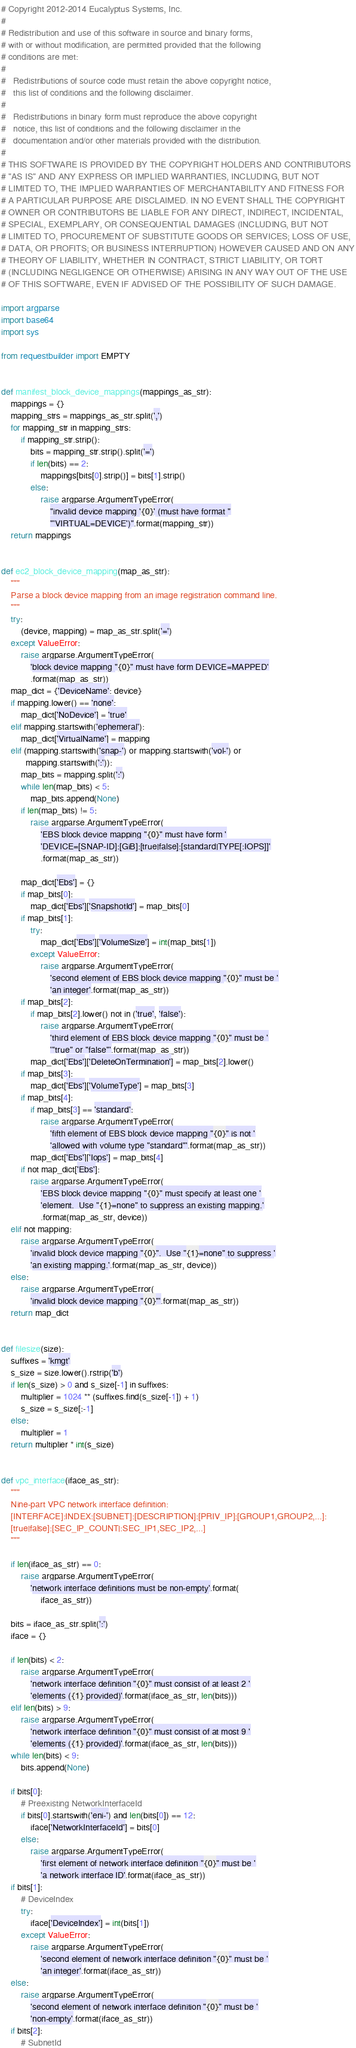<code> <loc_0><loc_0><loc_500><loc_500><_Python_># Copyright 2012-2014 Eucalyptus Systems, Inc.
#
# Redistribution and use of this software in source and binary forms,
# with or without modification, are permitted provided that the following
# conditions are met:
#
#   Redistributions of source code must retain the above copyright notice,
#   this list of conditions and the following disclaimer.
#
#   Redistributions in binary form must reproduce the above copyright
#   notice, this list of conditions and the following disclaimer in the
#   documentation and/or other materials provided with the distribution.
#
# THIS SOFTWARE IS PROVIDED BY THE COPYRIGHT HOLDERS AND CONTRIBUTORS
# "AS IS" AND ANY EXPRESS OR IMPLIED WARRANTIES, INCLUDING, BUT NOT
# LIMITED TO, THE IMPLIED WARRANTIES OF MERCHANTABILITY AND FITNESS FOR
# A PARTICULAR PURPOSE ARE DISCLAIMED. IN NO EVENT SHALL THE COPYRIGHT
# OWNER OR CONTRIBUTORS BE LIABLE FOR ANY DIRECT, INDIRECT, INCIDENTAL,
# SPECIAL, EXEMPLARY, OR CONSEQUENTIAL DAMAGES (INCLUDING, BUT NOT
# LIMITED TO, PROCUREMENT OF SUBSTITUTE GOODS OR SERVICES; LOSS OF USE,
# DATA, OR PROFITS; OR BUSINESS INTERRUPTION) HOWEVER CAUSED AND ON ANY
# THEORY OF LIABILITY, WHETHER IN CONTRACT, STRICT LIABILITY, OR TORT
# (INCLUDING NEGLIGENCE OR OTHERWISE) ARISING IN ANY WAY OUT OF THE USE
# OF THIS SOFTWARE, EVEN IF ADVISED OF THE POSSIBILITY OF SUCH DAMAGE.

import argparse
import base64
import sys

from requestbuilder import EMPTY


def manifest_block_device_mappings(mappings_as_str):
    mappings = {}
    mapping_strs = mappings_as_str.split(',')
    for mapping_str in mapping_strs:
        if mapping_str.strip():
            bits = mapping_str.strip().split('=')
            if len(bits) == 2:
                mappings[bits[0].strip()] = bits[1].strip()
            else:
                raise argparse.ArgumentTypeError(
                    "invalid device mapping '{0}' (must have format "
                    "'VIRTUAL=DEVICE')".format(mapping_str))
    return mappings


def ec2_block_device_mapping(map_as_str):
    """
    Parse a block device mapping from an image registration command line.
    """
    try:
        (device, mapping) = map_as_str.split('=')
    except ValueError:
        raise argparse.ArgumentTypeError(
            'block device mapping "{0}" must have form DEVICE=MAPPED'
            .format(map_as_str))
    map_dict = {'DeviceName': device}
    if mapping.lower() == 'none':
        map_dict['NoDevice'] = 'true'
    elif mapping.startswith('ephemeral'):
        map_dict['VirtualName'] = mapping
    elif (mapping.startswith('snap-') or mapping.startswith('vol-') or
          mapping.startswith(':')):
        map_bits = mapping.split(':')
        while len(map_bits) < 5:
            map_bits.append(None)
        if len(map_bits) != 5:
            raise argparse.ArgumentTypeError(
                'EBS block device mapping "{0}" must have form '
                'DEVICE=[SNAP-ID]:[GiB]:[true|false]:[standard|TYPE[:IOPS]]'
                .format(map_as_str))

        map_dict['Ebs'] = {}
        if map_bits[0]:
            map_dict['Ebs']['SnapshotId'] = map_bits[0]
        if map_bits[1]:
            try:
                map_dict['Ebs']['VolumeSize'] = int(map_bits[1])
            except ValueError:
                raise argparse.ArgumentTypeError(
                    'second element of EBS block device mapping "{0}" must be '
                    'an integer'.format(map_as_str))
        if map_bits[2]:
            if map_bits[2].lower() not in ('true', 'false'):
                raise argparse.ArgumentTypeError(
                    'third element of EBS block device mapping "{0}" must be '
                    '"true" or "false"'.format(map_as_str))
            map_dict['Ebs']['DeleteOnTermination'] = map_bits[2].lower()
        if map_bits[3]:
            map_dict['Ebs']['VolumeType'] = map_bits[3]
        if map_bits[4]:
            if map_bits[3] == 'standard':
                raise argparse.ArgumentTypeError(
                    'fifth element of EBS block device mapping "{0}" is not '
                    'allowed with volume type "standard"'.format(map_as_str))
            map_dict['Ebs']['Iops'] = map_bits[4]
        if not map_dict['Ebs']:
            raise argparse.ArgumentTypeError(
                'EBS block device mapping "{0}" must specify at least one '
                'element.  Use "{1}=none" to suppress an existing mapping.'
                .format(map_as_str, device))
    elif not mapping:
        raise argparse.ArgumentTypeError(
            'invalid block device mapping "{0}".  Use "{1}=none" to suppress '
            'an existing mapping.'.format(map_as_str, device))
    else:
        raise argparse.ArgumentTypeError(
            'invalid block device mapping "{0}"'.format(map_as_str))
    return map_dict


def filesize(size):
    suffixes = 'kmgt'
    s_size = size.lower().rstrip('b')
    if len(s_size) > 0 and s_size[-1] in suffixes:
        multiplier = 1024 ** (suffixes.find(s_size[-1]) + 1)
        s_size = s_size[:-1]
    else:
        multiplier = 1
    return multiplier * int(s_size)


def vpc_interface(iface_as_str):
    """
    Nine-part VPC network interface definition:
    [INTERFACE]:INDEX:[SUBNET]:[DESCRIPTION]:[PRIV_IP]:[GROUP1,GROUP2,...]:
    [true|false]:[SEC_IP_COUNT|:SEC_IP1,SEC_IP2,...]
    """

    if len(iface_as_str) == 0:
        raise argparse.ArgumentTypeError(
            'network interface definitions must be non-empty'.format(
                iface_as_str))

    bits = iface_as_str.split(':')
    iface = {}

    if len(bits) < 2:
        raise argparse.ArgumentTypeError(
            'network interface definition "{0}" must consist of at least 2 '
            'elements ({1} provided)'.format(iface_as_str, len(bits)))
    elif len(bits) > 9:
        raise argparse.ArgumentTypeError(
            'network interface definition "{0}" must consist of at most 9 '
            'elements ({1} provided)'.format(iface_as_str, len(bits)))
    while len(bits) < 9:
        bits.append(None)

    if bits[0]:
        # Preexisting NetworkInterfaceId
        if bits[0].startswith('eni-') and len(bits[0]) == 12:
            iface['NetworkInterfaceId'] = bits[0]
        else:
            raise argparse.ArgumentTypeError(
                'first element of network interface definition "{0}" must be '
                'a network interface ID'.format(iface_as_str))
    if bits[1]:
        # DeviceIndex
        try:
            iface['DeviceIndex'] = int(bits[1])
        except ValueError:
            raise argparse.ArgumentTypeError(
                'second element of network interface definition "{0}" must be '
                'an integer'.format(iface_as_str))
    else:
        raise argparse.ArgumentTypeError(
            'second element of network interface definition "{0}" must be '
            'non-empty'.format(iface_as_str))
    if bits[2]:
        # SubnetId</code> 